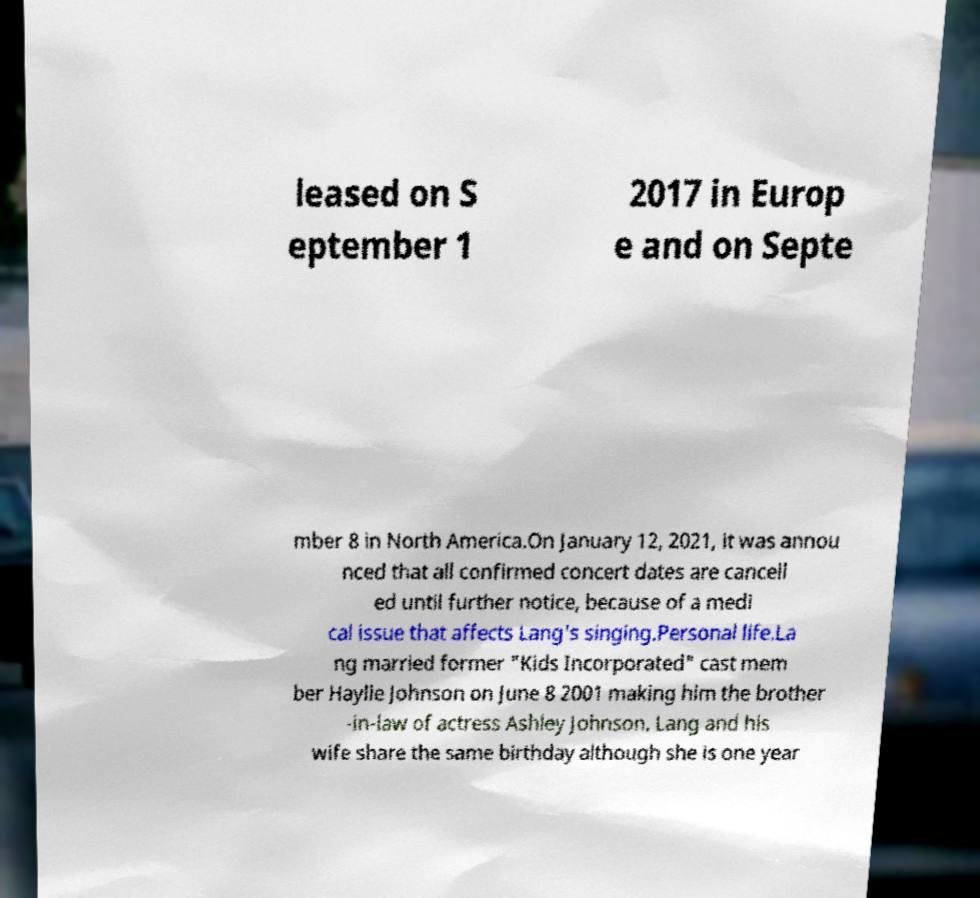Please read and relay the text visible in this image. What does it say? leased on S eptember 1 2017 in Europ e and on Septe mber 8 in North America.On January 12, 2021, it was annou nced that all confirmed concert dates are cancell ed until further notice, because of a medi cal issue that affects Lang's singing.Personal life.La ng married former "Kids Incorporated" cast mem ber Haylie Johnson on June 8 2001 making him the brother -in-law of actress Ashley Johnson. Lang and his wife share the same birthday although she is one year 